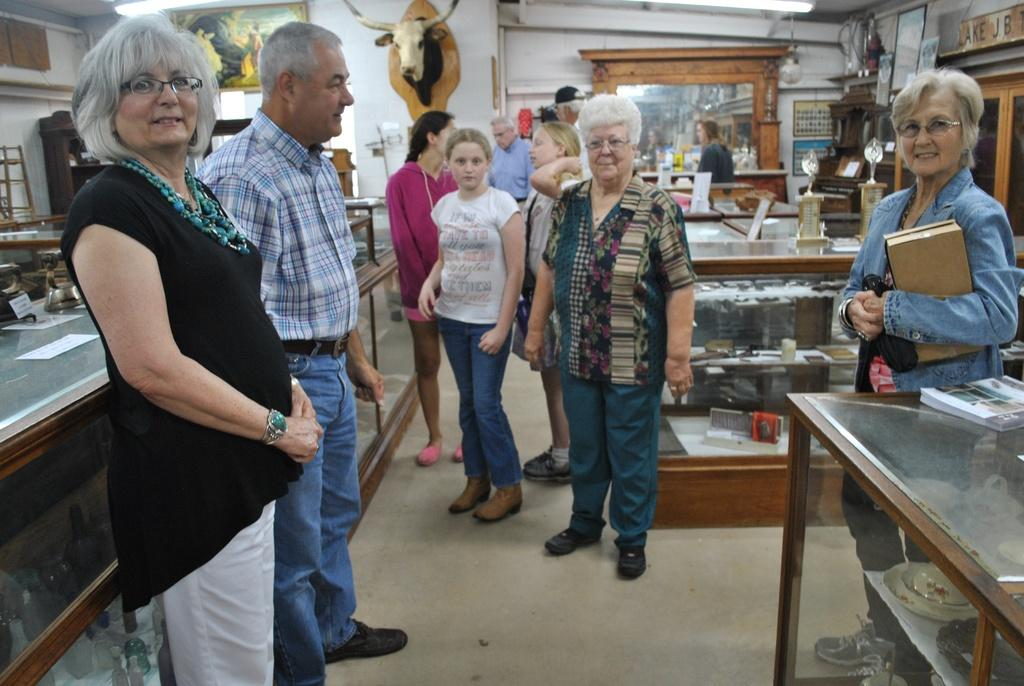What are the people in the image doing? There is a group of people on the floor in the image. What is the woman holding in the image? A woman is holding a box in the image. What type of objects can be seen in the image? There are wooden objects in the image. What is visible in the background of the image? There is a wall in the image. What is another object present in the image? There is a mirror in the image. What record did the group of people break in the image? There is no record-breaking activity depicted in the image; it simply shows a group of people on the floor and a woman holding a box. How does the achiever in the image feel about their accomplishment? There is no achiever or accomplishment mentioned in the image; it only shows a group of people on the floor and a woman holding a box. 